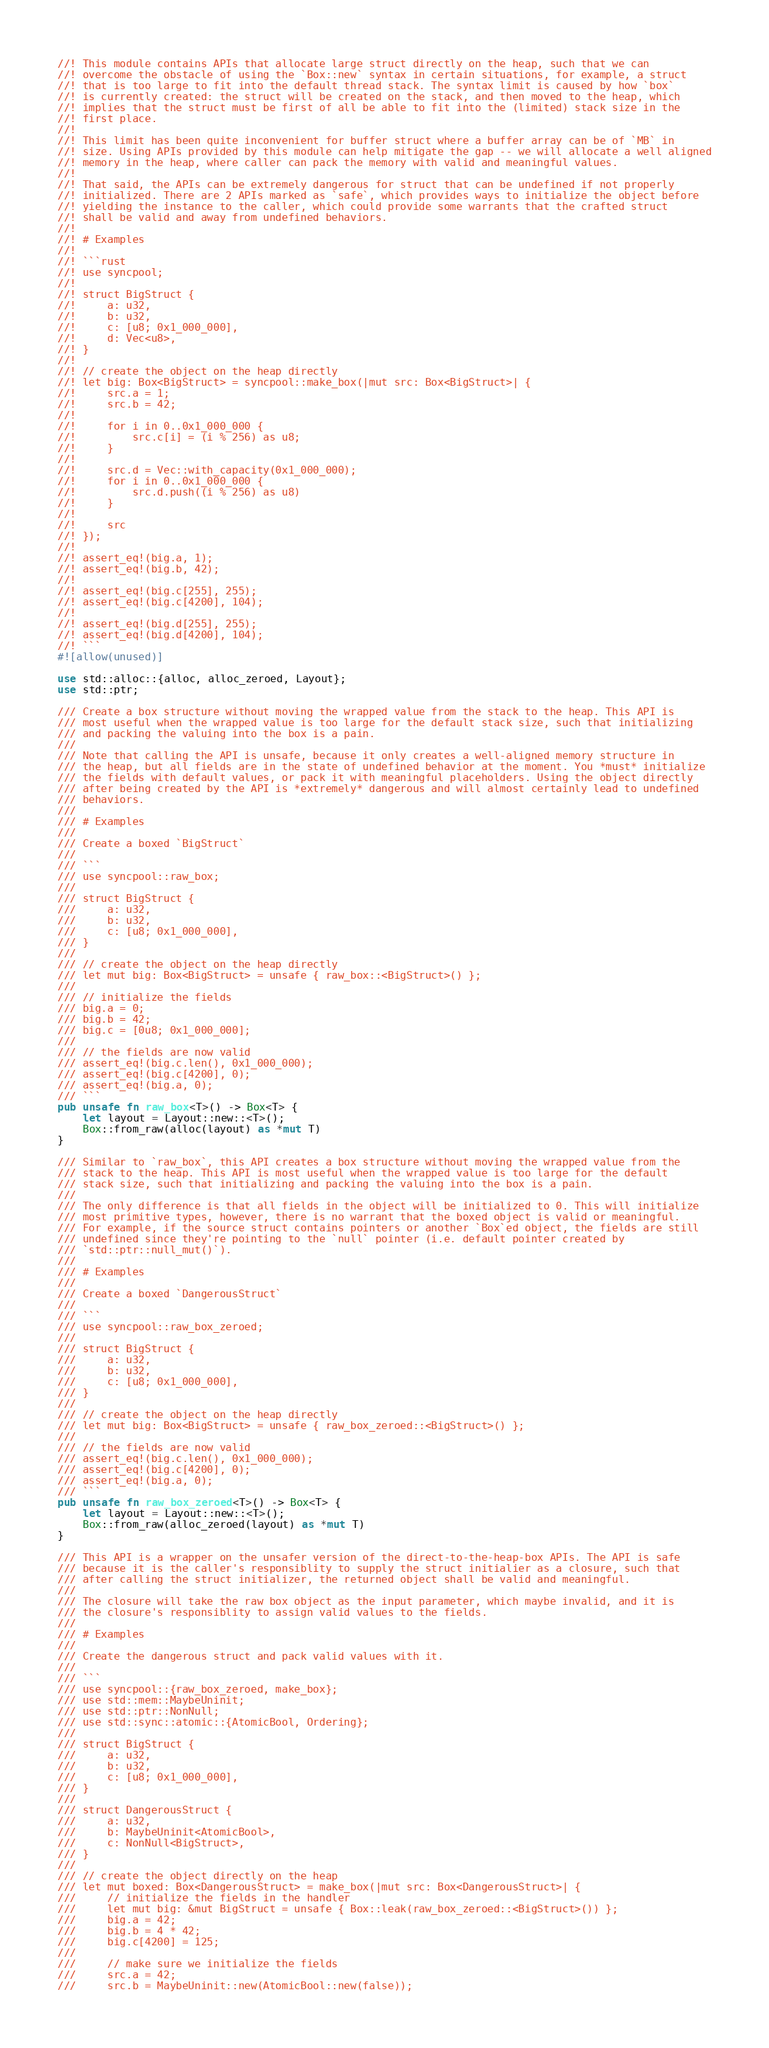<code> <loc_0><loc_0><loc_500><loc_500><_Rust_>//! This module contains APIs that allocate large struct directly on the heap, such that we can
//! overcome the obstacle of using the `Box::new` syntax in certain situations, for example, a struct
//! that is too large to fit into the default thread stack. The syntax limit is caused by how `box`
//! is currently created: the struct will be created on the stack, and then moved to the heap, which
//! implies that the struct must be first of all be able to fit into the (limited) stack size in the
//! first place.
//!
//! This limit has been quite inconvenient for buffer struct where a buffer array can be of `MB` in
//! size. Using APIs provided by this module can help mitigate the gap -- we will allocate a well aligned
//! memory in the heap, where caller can pack the memory with valid and meaningful values.
//!
//! That said, the APIs can be extremely dangerous for struct that can be undefined if not properly
//! initialized. There are 2 APIs marked as `safe`, which provides ways to initialize the object before
//! yielding the instance to the caller, which could provide some warrants that the crafted struct
//! shall be valid and away from undefined behaviors.
//!
//! # Examples
//!
//! ```rust
//! use syncpool;
//!
//! struct BigStruct {
//!     a: u32,
//!     b: u32,
//!     c: [u8; 0x1_000_000],
//!     d: Vec<u8>,
//! }
//!
//! // create the object on the heap directly
//! let big: Box<BigStruct> = syncpool::make_box(|mut src: Box<BigStruct>| {
//!     src.a = 1;
//!     src.b = 42;
//!
//!     for i in 0..0x1_000_000 {
//!         src.c[i] = (i % 256) as u8;
//!     }
//!
//!     src.d = Vec::with_capacity(0x1_000_000);
//!     for i in 0..0x1_000_000 {
//!         src.d.push((i % 256) as u8)
//!     }
//!
//!     src
//! });
//!
//! assert_eq!(big.a, 1);
//! assert_eq!(big.b, 42);
//!
//! assert_eq!(big.c[255], 255);
//! assert_eq!(big.c[4200], 104);
//!
//! assert_eq!(big.d[255], 255);
//! assert_eq!(big.d[4200], 104);
//! ```
#![allow(unused)]

use std::alloc::{alloc, alloc_zeroed, Layout};
use std::ptr;

/// Create a box structure without moving the wrapped value from the stack to the heap. This API is
/// most useful when the wrapped value is too large for the default stack size, such that initializing
/// and packing the valuing into the box is a pain.
///
/// Note that calling the API is unsafe, because it only creates a well-aligned memory structure in
/// the heap, but all fields are in the state of undefined behavior at the moment. You *must* initialize
/// the fields with default values, or pack it with meaningful placeholders. Using the object directly
/// after being created by the API is *extremely* dangerous and will almost certainly lead to undefined
/// behaviors.
///
/// # Examples
///
/// Create a boxed `BigStruct`
///
/// ```
/// use syncpool::raw_box;
///
/// struct BigStruct {
///     a: u32,
///     b: u32,
///     c: [u8; 0x1_000_000],
/// }
///
/// // create the object on the heap directly
/// let mut big: Box<BigStruct> = unsafe { raw_box::<BigStruct>() };
///
/// // initialize the fields
/// big.a = 0;
/// big.b = 42;
/// big.c = [0u8; 0x1_000_000];
///
/// // the fields are now valid
/// assert_eq!(big.c.len(), 0x1_000_000);
/// assert_eq!(big.c[4200], 0);
/// assert_eq!(big.a, 0);
/// ```
pub unsafe fn raw_box<T>() -> Box<T> {
    let layout = Layout::new::<T>();
    Box::from_raw(alloc(layout) as *mut T)
}

/// Similar to `raw_box`, this API creates a box structure without moving the wrapped value from the
/// stack to the heap. This API is most useful when the wrapped value is too large for the default
/// stack size, such that initializing and packing the valuing into the box is a pain.
///
/// The only difference is that all fields in the object will be initialized to 0. This will initialize
/// most primitive types, however, there is no warrant that the boxed object is valid or meaningful.
/// For example, if the source struct contains pointers or another `Box`ed object, the fields are still
/// undefined since they're pointing to the `null` pointer (i.e. default pointer created by
/// `std::ptr::null_mut()`).
///
/// # Examples
///
/// Create a boxed `DangerousStruct`
///
/// ```
/// use syncpool::raw_box_zeroed;
///
/// struct BigStruct {
///     a: u32,
///     b: u32,
///     c: [u8; 0x1_000_000],
/// }
///
/// // create the object on the heap directly
/// let mut big: Box<BigStruct> = unsafe { raw_box_zeroed::<BigStruct>() };
///
/// // the fields are now valid
/// assert_eq!(big.c.len(), 0x1_000_000);
/// assert_eq!(big.c[4200], 0);
/// assert_eq!(big.a, 0);
/// ```
pub unsafe fn raw_box_zeroed<T>() -> Box<T> {
    let layout = Layout::new::<T>();
    Box::from_raw(alloc_zeroed(layout) as *mut T)
}

/// This API is a wrapper on the unsafer version of the direct-to-the-heap-box APIs. The API is safe
/// because it is the caller's responsiblity to supply the struct initialier as a closure, such that
/// after calling the struct initializer, the returned object shall be valid and meaningful.
///
/// The closure will take the raw box object as the input parameter, which maybe invalid, and it is
/// the closure's responsiblity to assign valid values to the fields.
///
/// # Examples
///
/// Create the dangerous struct and pack valid values with it.
///
/// ```
/// use syncpool::{raw_box_zeroed, make_box};
/// use std::mem::MaybeUninit;
/// use std::ptr::NonNull;
/// use std::sync::atomic::{AtomicBool, Ordering};
///
/// struct BigStruct {
///     a: u32,
///     b: u32,
///     c: [u8; 0x1_000_000],
/// }
///
/// struct DangerousStruct {
///     a: u32,
///     b: MaybeUninit<AtomicBool>,
///     c: NonNull<BigStruct>,
/// }
///
/// // create the object directly on the heap
/// let mut boxed: Box<DangerousStruct> = make_box(|mut src: Box<DangerousStruct>| {
///     // initialize the fields in the handler
///     let mut big: &mut BigStruct = unsafe { Box::leak(raw_box_zeroed::<BigStruct>()) };
///     big.a = 42;
///     big.b = 4 * 42;
///     big.c[4200] = 125;
///
///     // make sure we initialize the fields
///     src.a = 42;
///     src.b = MaybeUninit::new(AtomicBool::new(false));</code> 